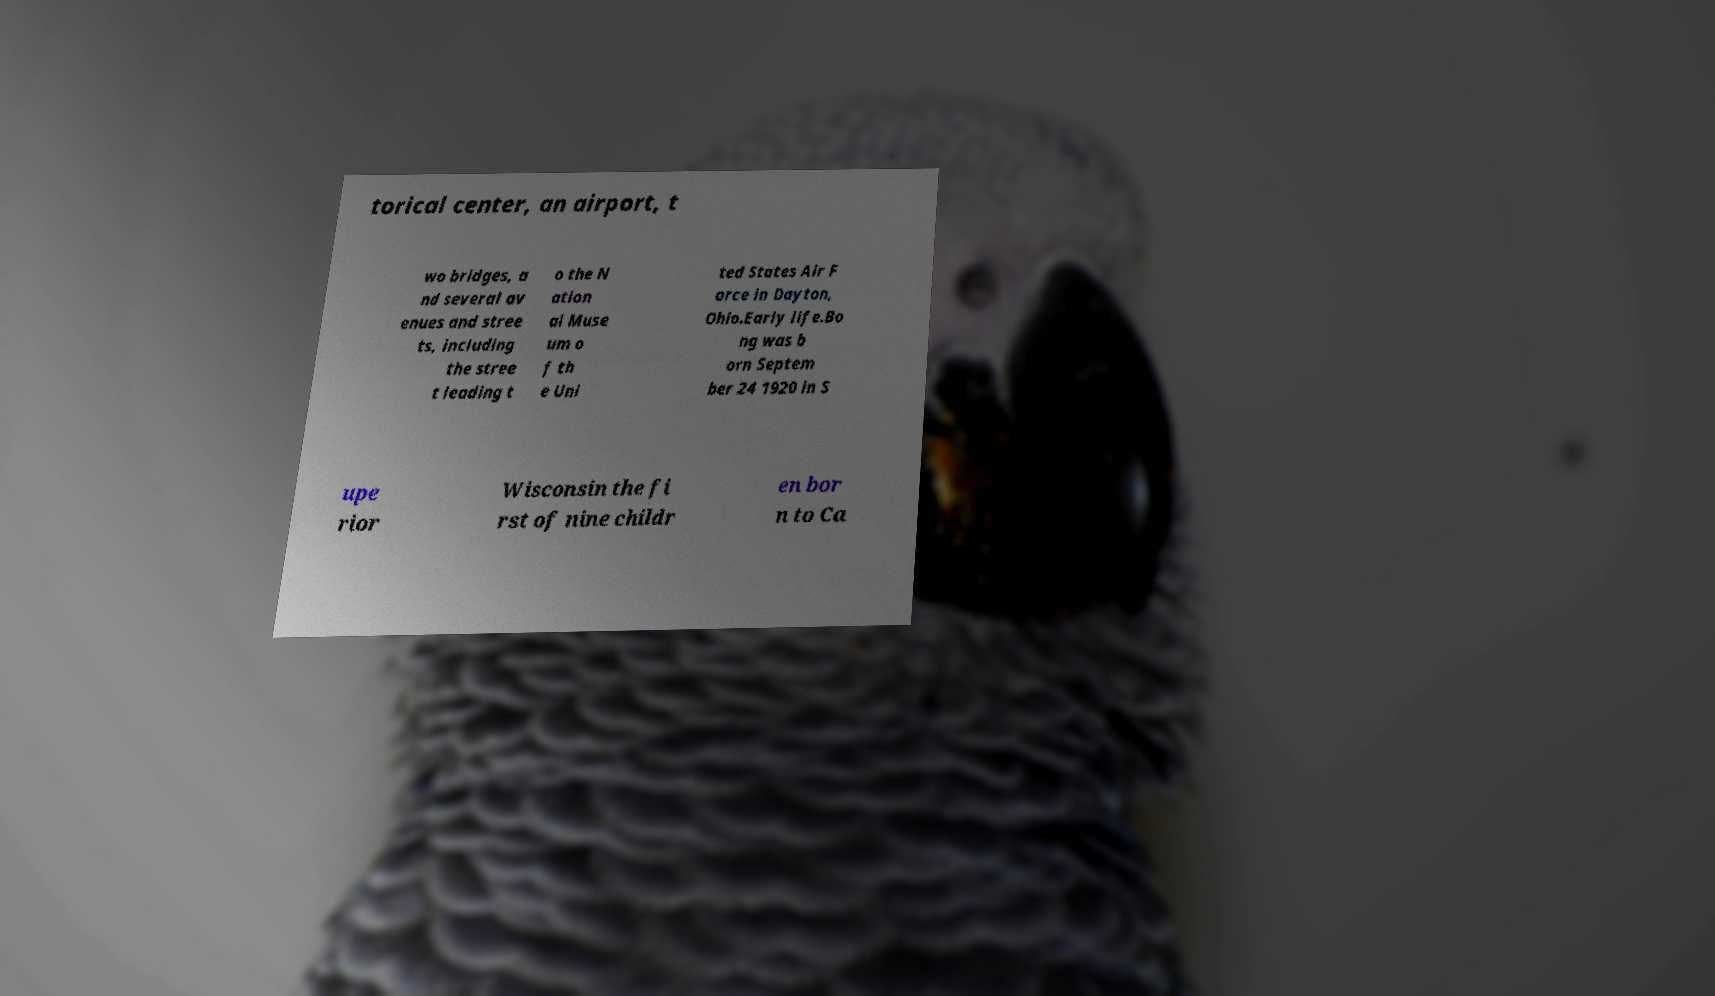There's text embedded in this image that I need extracted. Can you transcribe it verbatim? torical center, an airport, t wo bridges, a nd several av enues and stree ts, including the stree t leading t o the N ation al Muse um o f th e Uni ted States Air F orce in Dayton, Ohio.Early life.Bo ng was b orn Septem ber 24 1920 in S upe rior Wisconsin the fi rst of nine childr en bor n to Ca 